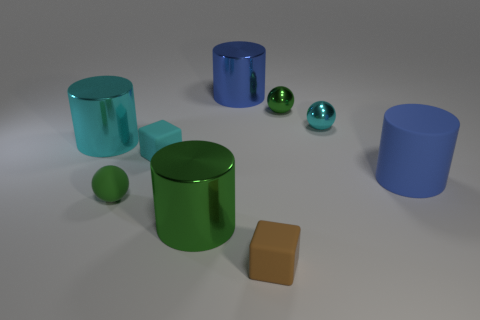Subtract all green cylinders. How many cylinders are left? 3 Subtract all small metal balls. How many balls are left? 1 Subtract all purple cylinders. Subtract all cyan blocks. How many cylinders are left? 4 Add 1 big gray metallic balls. How many objects exist? 10 Subtract 0 red spheres. How many objects are left? 9 Subtract all blocks. How many objects are left? 7 Subtract all tiny brown matte cubes. Subtract all brown cubes. How many objects are left? 7 Add 7 spheres. How many spheres are left? 10 Add 2 cyan metal things. How many cyan metal things exist? 4 